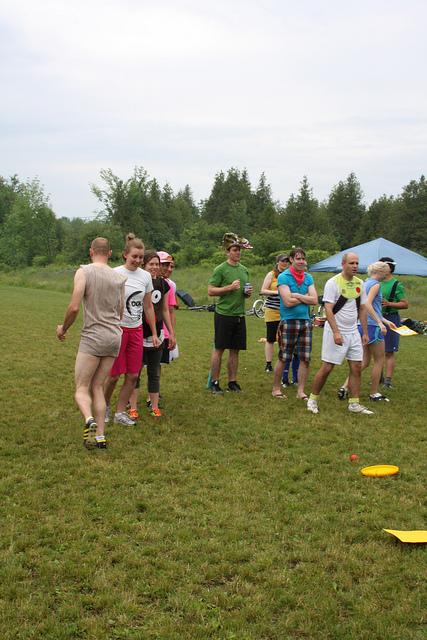How many people are not wearing shorts?
Give a very brief answer. 1. How many people are in this picture?
Quick response, please. 10. Is there a yellow frisbee?
Be succinct. Yes. 